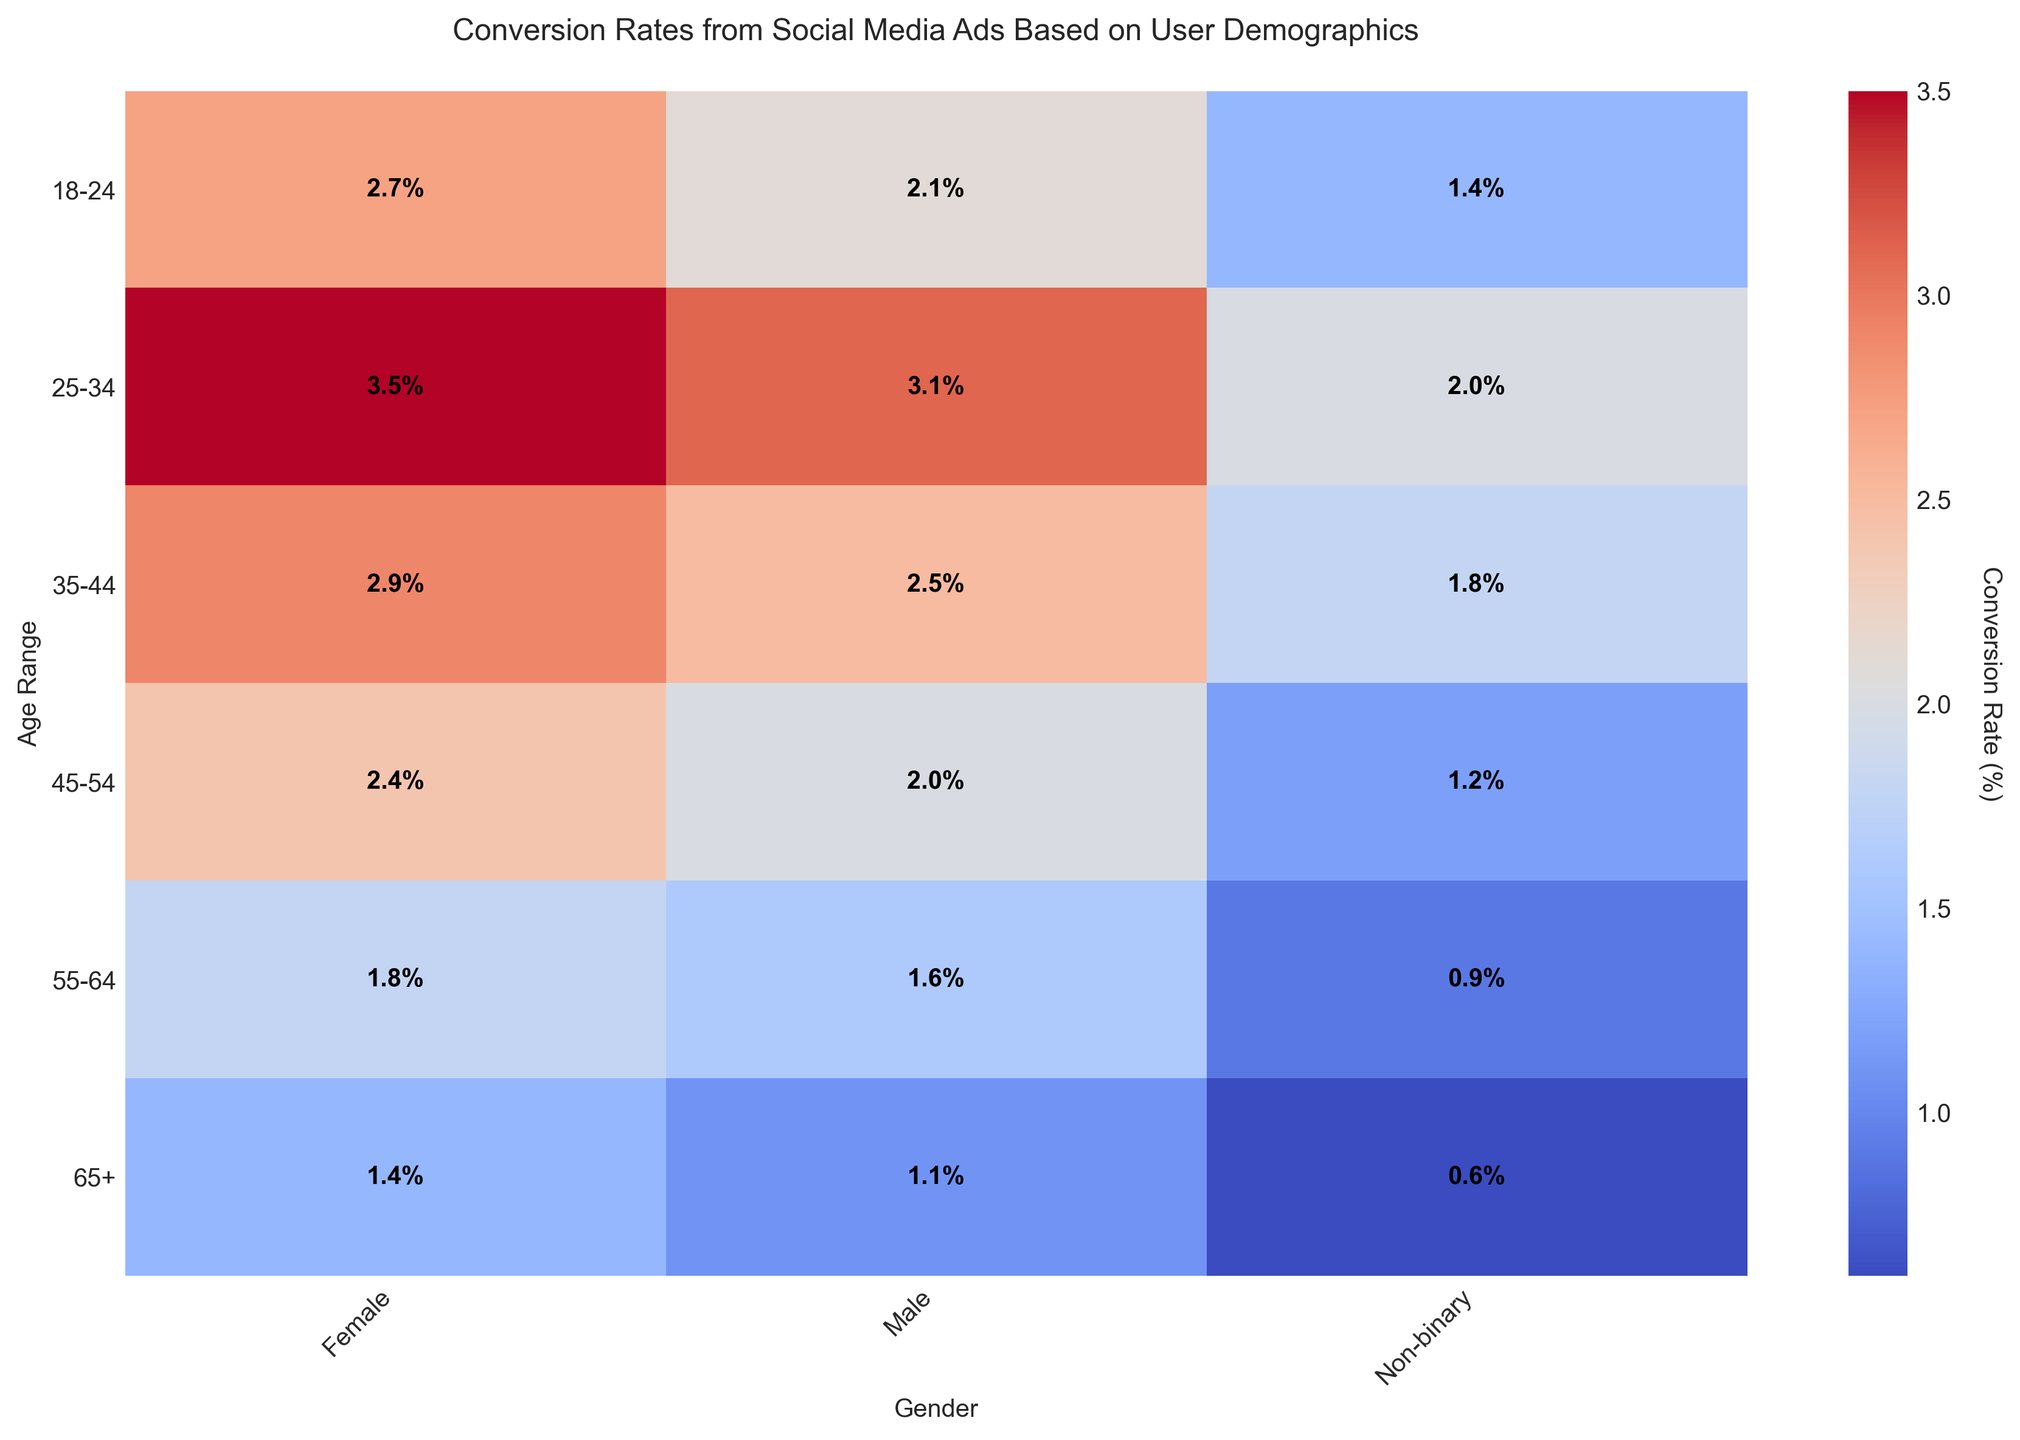Which age range and gender combination has the highest conversion rate? By observing the highest value in the heatmap, we find that the age range 25-34 for females has the highest conversion rate.
Answer: 25-34 Female What is the difference in conversion rates between 18-24 year-old males and 35-44 year-old females? From the heatmap, 18-24 year-old males have a conversion rate of 2.1%, and 35-44 year-old females have a conversion rate of 2.9%. The difference is 2.9% - 2.1% = 0.8%.
Answer: 0.8% Identify the age and gender combination with the lowest conversion rate. By locating the smallest value on the heatmap, we see that the age range 65+ for non-binary individuals has the lowest conversion rate.
Answer: 65+ Non-binary Which gender has the smallest variation in conversion rates across all age ranges? By examining the heatmap ranges for each gender, non-binary individuals have the smallest variation, with values ranging from 0.6% to 2.0%.
Answer: Non-binary What is the average conversion rate for all 25-34 year-olds? The conversion rates for 25-34 year-olds are 3.1% for males, 3.5% for females, and 2.0% for non-binary individuals. The average is (3.1 + 3.5 + 2.0) / 3 = 2.87%.
Answer: 2.87% Compare the conversion rates of males and females in the 45-54 age range. From the heatmap, males in the 45-54 age range have a conversion rate of 2.0%, and females have a conversion rate of 2.4%. Females have a higher conversion rate in this age range.
Answer: Females have a higher conversion rate What is the sum of conversion rates for all genders in the 18-24 age group? The conversion rates for 18-24 year-olds are 2.1% for males, 2.7% for females, and 1.4% for non-binary individuals. The sum is 2.1 + 2.7 + 1.4 = 6.2%.
Answer: 6.2% Which gender shows a steady decline in conversion rates as age increases? By observing the trend in the heatmap for each gender across age ranges, males show a steady decline in conversion rates as age increases.
Answer: Male Which age range shows the highest disparity in conversion rates among different genders? The 25-34 age range shows the highest disparity, with conversion rates of 3.1% for males, 3.5% for females, and 2.0% for non-binary individuals. The difference between the highest and lowest conversion rates is 3.5% - 2.0% = 1.5%.
Answer: 25-34 How does the conversion rate for 55-64 year-old females compare to that of 18-24 year-old non-binary individuals? 55-64 year-old females have a conversion rate of 1.8%, and 18-24 year-old non-binary individuals have a conversion rate of 1.4%. The conversion rate is higher for 55-64 year-old females.
Answer: 55-64 year-old females have higher conversion rates 